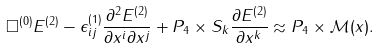Convert formula to latex. <formula><loc_0><loc_0><loc_500><loc_500>\Box ^ { ( 0 ) } E ^ { ( 2 ) } - \epsilon _ { i j } ^ { ( 1 ) } \frac { \partial ^ { 2 } E ^ { ( 2 ) } } { \partial x ^ { i } \partial x ^ { j } } + P _ { 4 } \times S _ { k } \frac { \partial E ^ { ( 2 ) } } { \partial x ^ { k } } \approx P _ { 4 } \times { \mathcal { M } } ( x ) .</formula> 